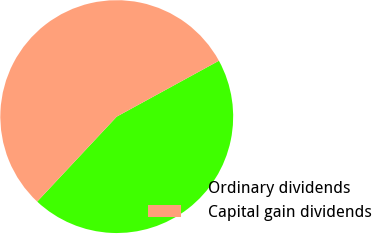Convert chart to OTSL. <chart><loc_0><loc_0><loc_500><loc_500><pie_chart><fcel>Ordinary dividends<fcel>Capital gain dividends<nl><fcel>44.94%<fcel>55.06%<nl></chart> 